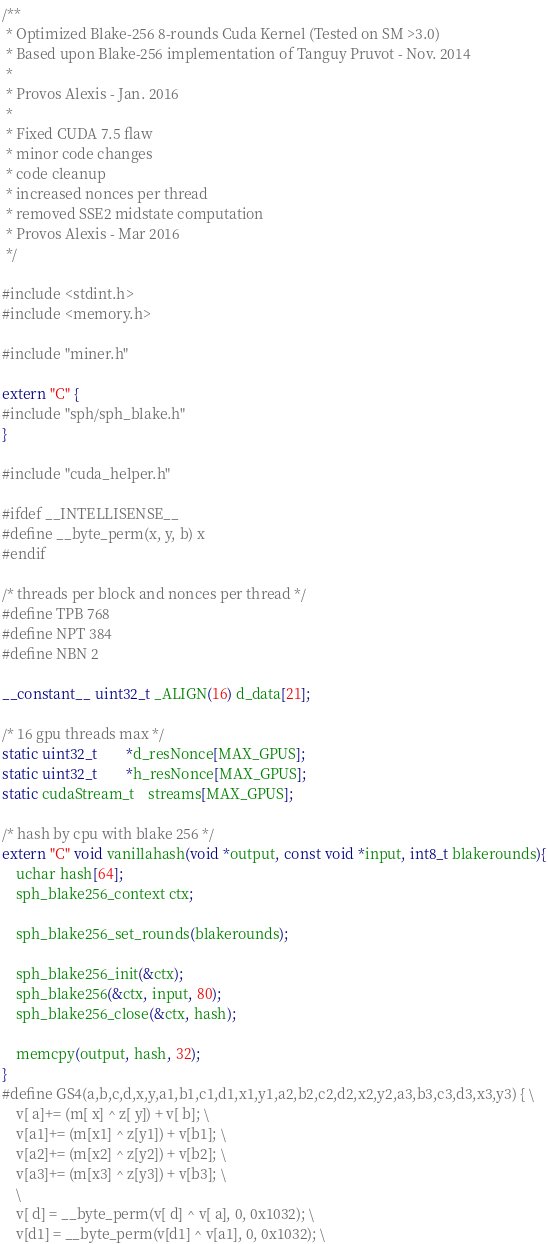Convert code to text. <code><loc_0><loc_0><loc_500><loc_500><_Cuda_>/**
 * Optimized Blake-256 8-rounds Cuda Kernel (Tested on SM >3.0)
 * Based upon Blake-256 implementation of Tanguy Pruvot - Nov. 2014
 *
 * Provos Alexis - Jan. 2016
 *
 * Fixed CUDA 7.5 flaw
 * minor code changes
 * code cleanup
 * increased nonces per thread
 * removed SSE2 midstate computation
 * Provos Alexis - Mar 2016
 */

#include <stdint.h>
#include <memory.h>

#include "miner.h"

extern "C" {
#include "sph/sph_blake.h"
}

#include "cuda_helper.h"

#ifdef __INTELLISENSE__
#define __byte_perm(x, y, b) x
#endif

/* threads per block and nonces per thread */
#define TPB 768
#define NPT 384
#define NBN 2

__constant__ uint32_t _ALIGN(16) d_data[21];

/* 16 gpu threads max */
static uint32_t		*d_resNonce[MAX_GPUS];
static uint32_t		*h_resNonce[MAX_GPUS];
static cudaStream_t	streams[MAX_GPUS];

/* hash by cpu with blake 256 */
extern "C" void vanillahash(void *output, const void *input, int8_t blakerounds){
	uchar hash[64];
	sph_blake256_context ctx;

	sph_blake256_set_rounds(blakerounds);

	sph_blake256_init(&ctx);
	sph_blake256(&ctx, input, 80);
	sph_blake256_close(&ctx, hash);

	memcpy(output, hash, 32);
}
#define GS4(a,b,c,d,x,y,a1,b1,c1,d1,x1,y1,a2,b2,c2,d2,x2,y2,a3,b3,c3,d3,x3,y3) { \
	v[ a]+= (m[ x] ^ z[ y]) + v[ b]; \
	v[a1]+= (m[x1] ^ z[y1]) + v[b1]; \
	v[a2]+= (m[x2] ^ z[y2]) + v[b2]; \
	v[a3]+= (m[x3] ^ z[y3]) + v[b3]; \
	\
	v[ d] = __byte_perm(v[ d] ^ v[ a], 0, 0x1032); \
	v[d1] = __byte_perm(v[d1] ^ v[a1], 0, 0x1032); \</code> 